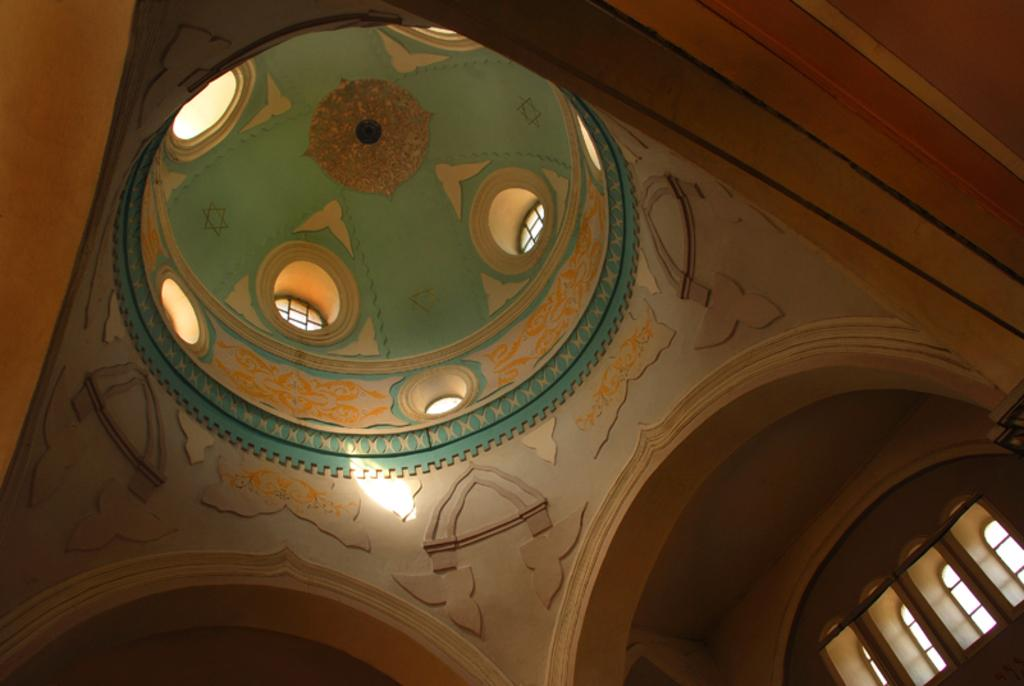What type of structure is present in the image? There is a building in the image. Can you describe any specific design elements on the building? Yes, there is a floral design on the roof of the building. Where are the windows located on the building? The windows are on the right side of the image. What additional feature can be seen in the image? There is a rod visible in the image. What type of glue is being used to attach the color to the building in the image? There is no mention of color or glue in the image; it only features a building with a floral design on the roof, windows, and a rod. 